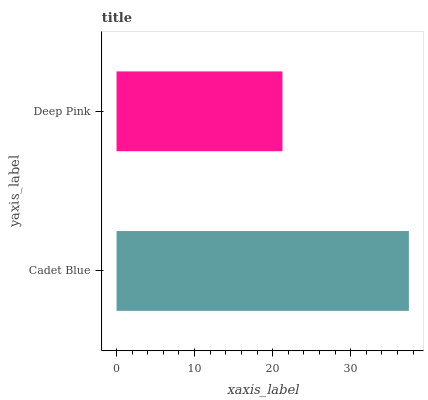Is Deep Pink the minimum?
Answer yes or no. Yes. Is Cadet Blue the maximum?
Answer yes or no. Yes. Is Deep Pink the maximum?
Answer yes or no. No. Is Cadet Blue greater than Deep Pink?
Answer yes or no. Yes. Is Deep Pink less than Cadet Blue?
Answer yes or no. Yes. Is Deep Pink greater than Cadet Blue?
Answer yes or no. No. Is Cadet Blue less than Deep Pink?
Answer yes or no. No. Is Cadet Blue the high median?
Answer yes or no. Yes. Is Deep Pink the low median?
Answer yes or no. Yes. Is Deep Pink the high median?
Answer yes or no. No. Is Cadet Blue the low median?
Answer yes or no. No. 